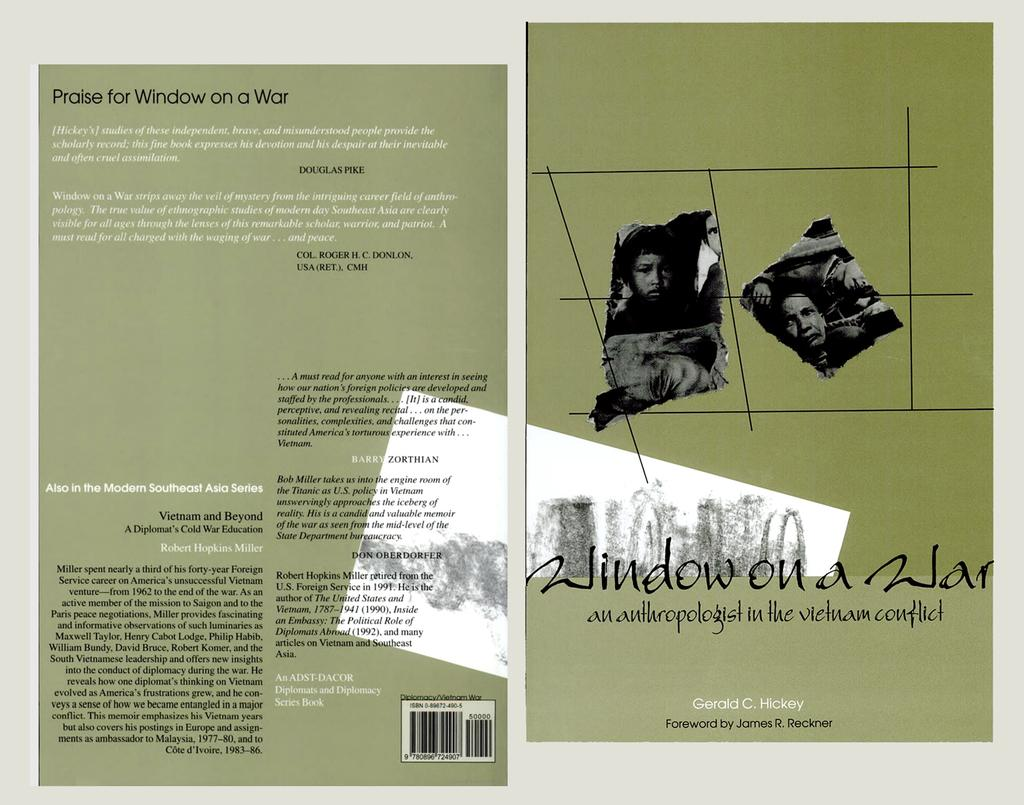What color are the papers in the image? The papers in the image are green. What is written or drawn on the papers? Words, numbers, and pictures of people are written or drawn on the papers. Can you identify any specific symbols or codes on the papers? Yes, a bar code is visible in the image. What type of lettuce is being used as a cap in the image? There is no lettuce or cap present in the image. What kind of toys can be seen playing with the papers in the image? There are no toys present in the image; it only features green color papers with words, numbers, pictures, and a bar code. 